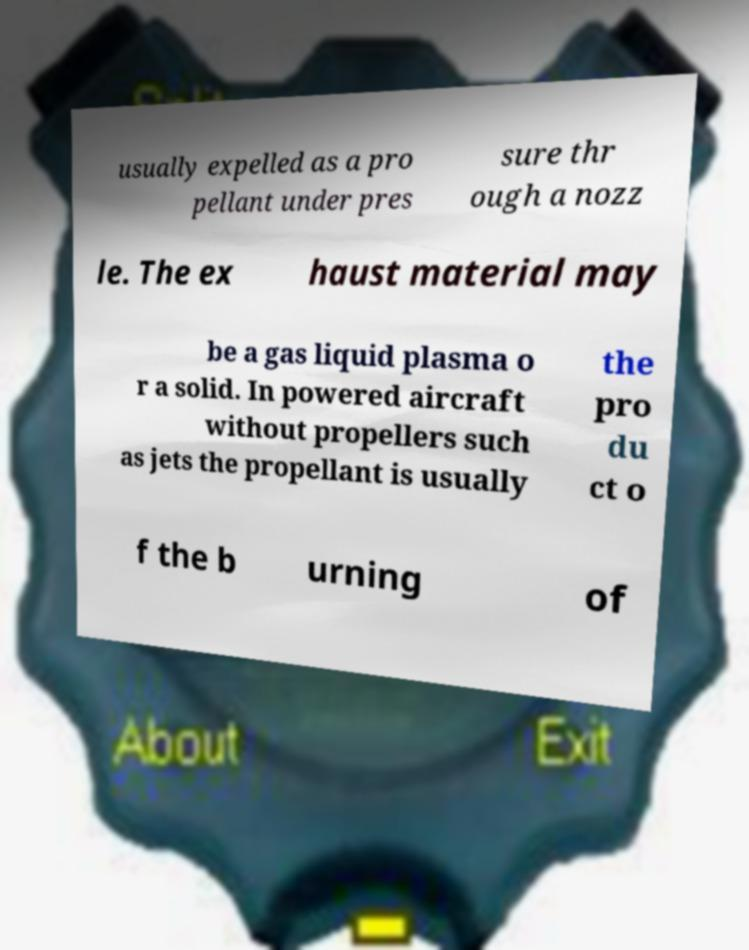I need the written content from this picture converted into text. Can you do that? usually expelled as a pro pellant under pres sure thr ough a nozz le. The ex haust material may be a gas liquid plasma o r a solid. In powered aircraft without propellers such as jets the propellant is usually the pro du ct o f the b urning of 